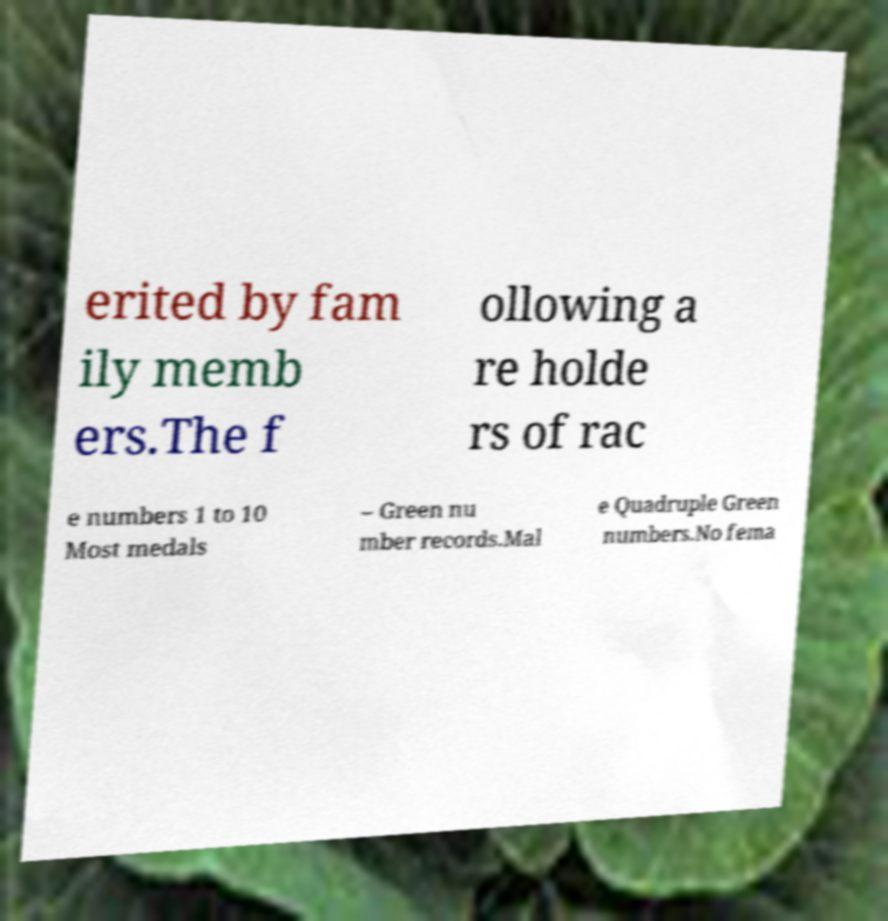Please identify and transcribe the text found in this image. erited by fam ily memb ers.The f ollowing a re holde rs of rac e numbers 1 to 10 Most medals – Green nu mber records.Mal e Quadruple Green numbers.No fema 